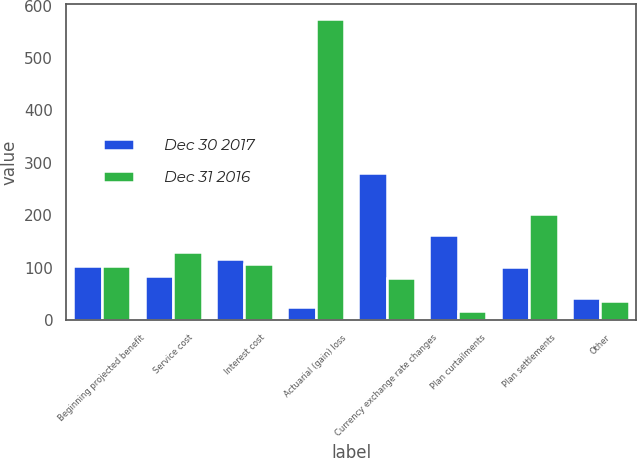Convert chart to OTSL. <chart><loc_0><loc_0><loc_500><loc_500><stacked_bar_chart><ecel><fcel>Beginning projected benefit<fcel>Service cost<fcel>Interest cost<fcel>Actuarial (gain) loss<fcel>Currency exchange rate changes<fcel>Plan curtailments<fcel>Plan settlements<fcel>Other<nl><fcel>Dec 30 2017<fcel>103.5<fcel>84<fcel>117<fcel>24<fcel>281<fcel>162<fcel>101<fcel>41<nl><fcel>Dec 31 2016<fcel>103.5<fcel>130<fcel>106<fcel>575<fcel>80<fcel>17<fcel>202<fcel>36<nl></chart> 